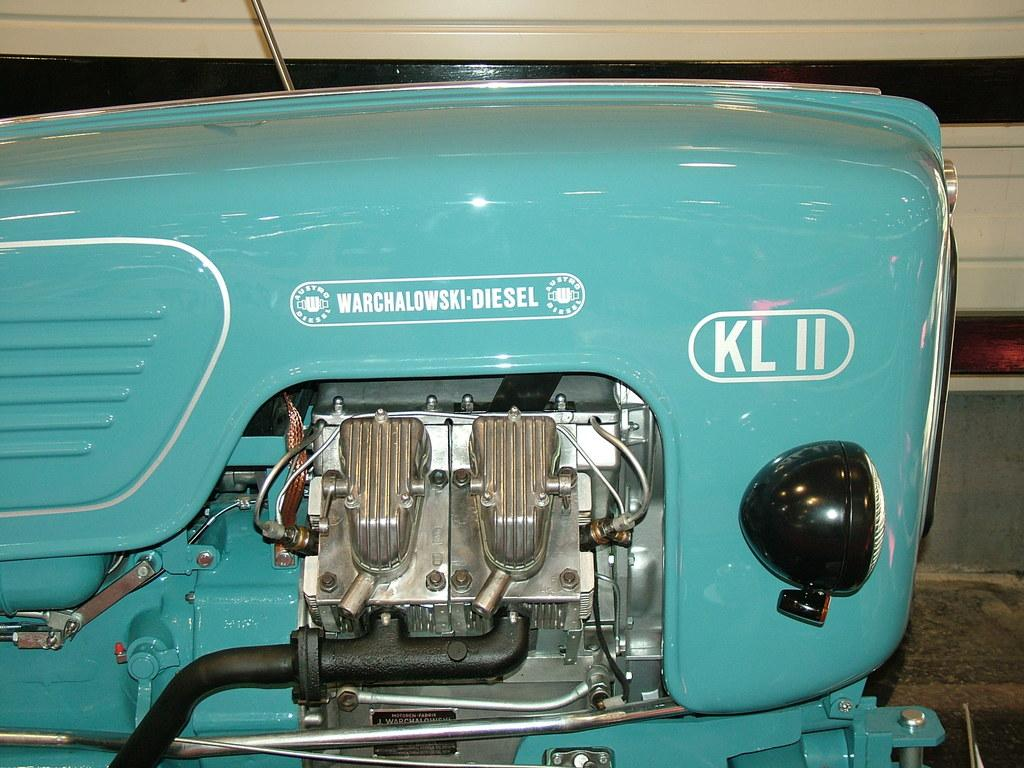What is the focus of the image? The image is a zoomed-in view of an object. Can you describe any text present in the image? There is text written in white color on the image. Is there a toothbrush being used in the image? There is no toothbrush present in the image. What action is being performed by the object in the image? The image is a zoomed-in view of an object, but it does not show any action being performed. --- Facts: 1. There is a person sitting on a chair in the image. 2. The person is holding a book. 3. The book has a blue cover. 4. The chair is made of wood. Absurd Topics: bicycle, ocean, parrot Conversation: What is the person in the image doing? The person is sitting on a chair in the image. What is the person holding in their hands? The person is holding a book. Can you describe the book's appearance? The book has a blue cover. What material is the chair made of? The chair is made of wood. Reasoning: Let's think step by step in order to produce the conversation. We start by identifying the main subject in the image, which is the person sitting on a chair. Then, we expand the conversation to include other items that are also visible, such as the book and the chair. Each question is designed to elicit a specific detail about the image that is known from the provided facts. Absurd Question/Answer: Can you see a bicycle in the image? There is no bicycle present in the image. What type of parrot is sitting on the person's shoulder in the image? There is no parrot present in the image. 